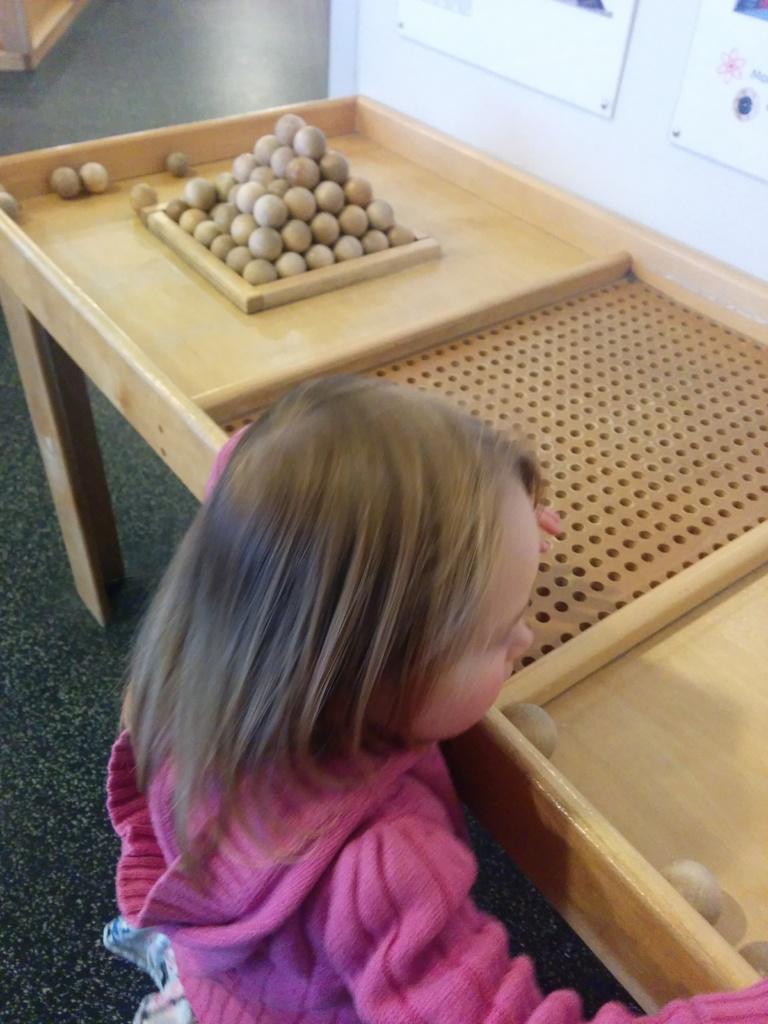Please provide a concise description of this image. This is a picture of a girl who is wearing a pink color top playing with the balls in the table like a game and behind her there are some group of balls in the table and at the background there are 2 hoardings attached to the wall. 